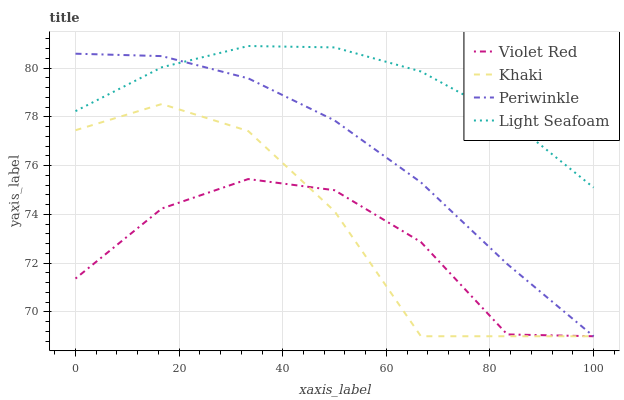Does Khaki have the minimum area under the curve?
Answer yes or no. No. Does Khaki have the maximum area under the curve?
Answer yes or no. No. Is Khaki the smoothest?
Answer yes or no. No. Is Periwinkle the roughest?
Answer yes or no. No. Does Light Seafoam have the lowest value?
Answer yes or no. No. Does Khaki have the highest value?
Answer yes or no. No. Is Khaki less than Light Seafoam?
Answer yes or no. Yes. Is Light Seafoam greater than Violet Red?
Answer yes or no. Yes. Does Khaki intersect Light Seafoam?
Answer yes or no. No. 